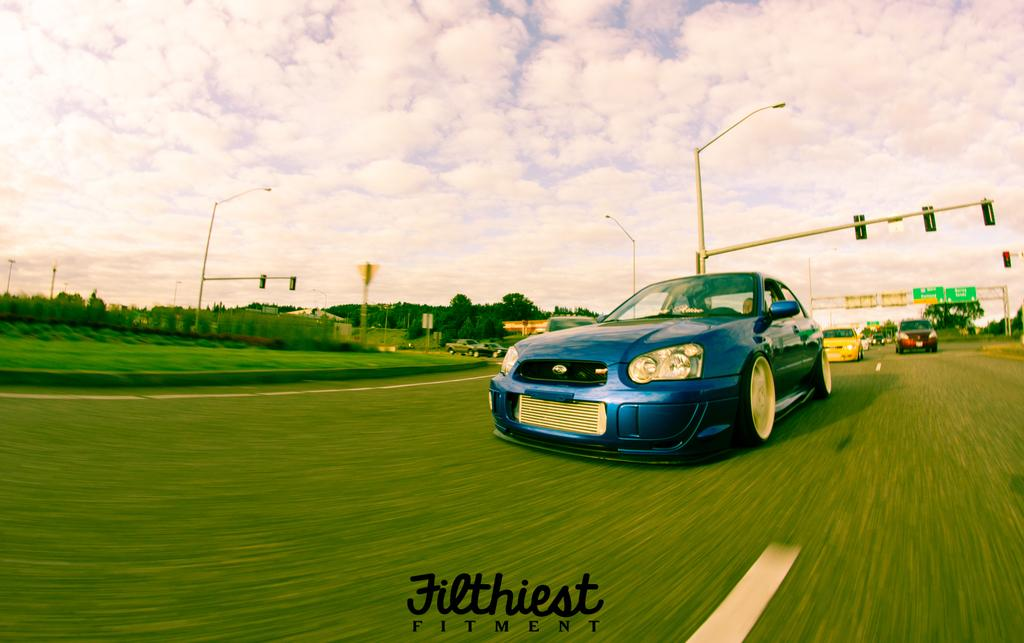What can be seen on the road in the image? There are cars on the road in the image. What type of vegetation is present in the image? There are trees and plants in the image. What structures are present along the road in the image? There are poles with boards and lights in the image. Can you see a giraffe walking through the trees in the image? No, there is no giraffe present in the image; it features cars on the road, trees, plants, and poles with boards and lights. Is there an argument happening between the trees in the image? There is no argument depicted in the image; it shows cars on the road, trees, plants, and poles with boards and lights. 